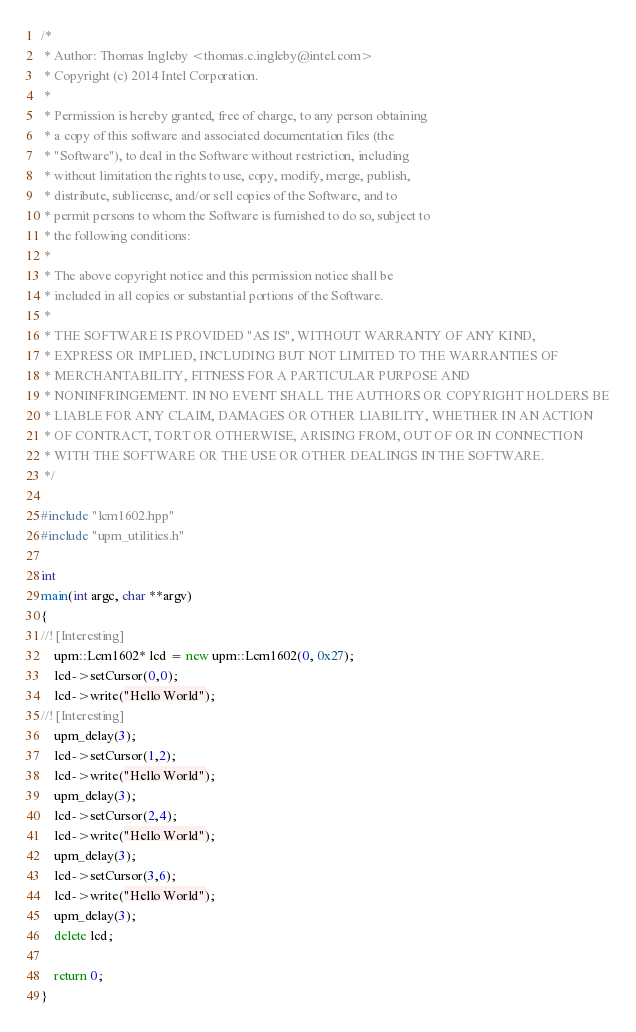<code> <loc_0><loc_0><loc_500><loc_500><_C++_>/*
 * Author: Thomas Ingleby <thomas.c.ingleby@intel.com>
 * Copyright (c) 2014 Intel Corporation.
 *
 * Permission is hereby granted, free of charge, to any person obtaining
 * a copy of this software and associated documentation files (the
 * "Software"), to deal in the Software without restriction, including
 * without limitation the rights to use, copy, modify, merge, publish,
 * distribute, sublicense, and/or sell copies of the Software, and to
 * permit persons to whom the Software is furnished to do so, subject to
 * the following conditions:
 *
 * The above copyright notice and this permission notice shall be
 * included in all copies or substantial portions of the Software.
 *
 * THE SOFTWARE IS PROVIDED "AS IS", WITHOUT WARRANTY OF ANY KIND,
 * EXPRESS OR IMPLIED, INCLUDING BUT NOT LIMITED TO THE WARRANTIES OF
 * MERCHANTABILITY, FITNESS FOR A PARTICULAR PURPOSE AND
 * NONINFRINGEMENT. IN NO EVENT SHALL THE AUTHORS OR COPYRIGHT HOLDERS BE
 * LIABLE FOR ANY CLAIM, DAMAGES OR OTHER LIABILITY, WHETHER IN AN ACTION
 * OF CONTRACT, TORT OR OTHERWISE, ARISING FROM, OUT OF OR IN CONNECTION
 * WITH THE SOFTWARE OR THE USE OR OTHER DEALINGS IN THE SOFTWARE.
 */

#include "lcm1602.hpp"
#include "upm_utilities.h"

int
main(int argc, char **argv)
{
//! [Interesting]
    upm::Lcm1602* lcd = new upm::Lcm1602(0, 0x27);
    lcd->setCursor(0,0);
    lcd->write("Hello World");
//! [Interesting]
    upm_delay(3);
    lcd->setCursor(1,2);
    lcd->write("Hello World");
    upm_delay(3);
    lcd->setCursor(2,4);
    lcd->write("Hello World");
    upm_delay(3);
    lcd->setCursor(3,6);
    lcd->write("Hello World");
    upm_delay(3);
    delete lcd;

    return 0;
}
</code> 